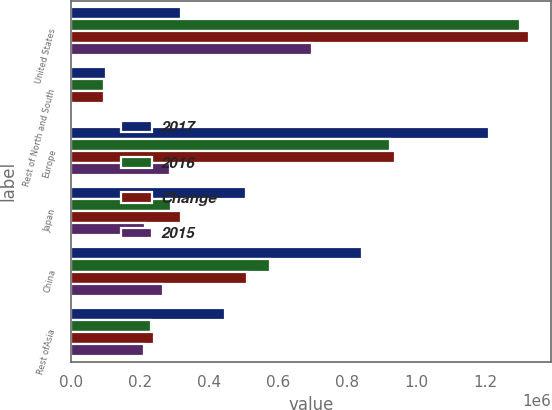Convert chart to OTSL. <chart><loc_0><loc_0><loc_500><loc_500><stacked_bar_chart><ecel><fcel>United States<fcel>Rest of North and South<fcel>Europe<fcel>Japan<fcel>China<fcel>Rest ofAsia<nl><fcel>2017<fcel>319569<fcel>103077<fcel>1.21144e+06<fcel>506114<fcel>842532<fcel>445304<nl><fcel>2016<fcel>1.29963e+06<fcel>95957<fcel>924849<fcel>291649<fcel>575690<fcel>233635<nl><fcel>Change<fcel>1.32528e+06<fcel>97189<fcel>939230<fcel>319569<fcel>511365<fcel>242460<nl><fcel>2015<fcel>699412<fcel>7120<fcel>286586<fcel>214465<fcel>266842<fcel>211669<nl></chart> 